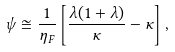Convert formula to latex. <formula><loc_0><loc_0><loc_500><loc_500>\psi \cong \frac { 1 } { \eta _ { F } } \left [ \frac { \lambda ( 1 + \lambda ) } { \kappa } - \kappa \right ] ,</formula> 